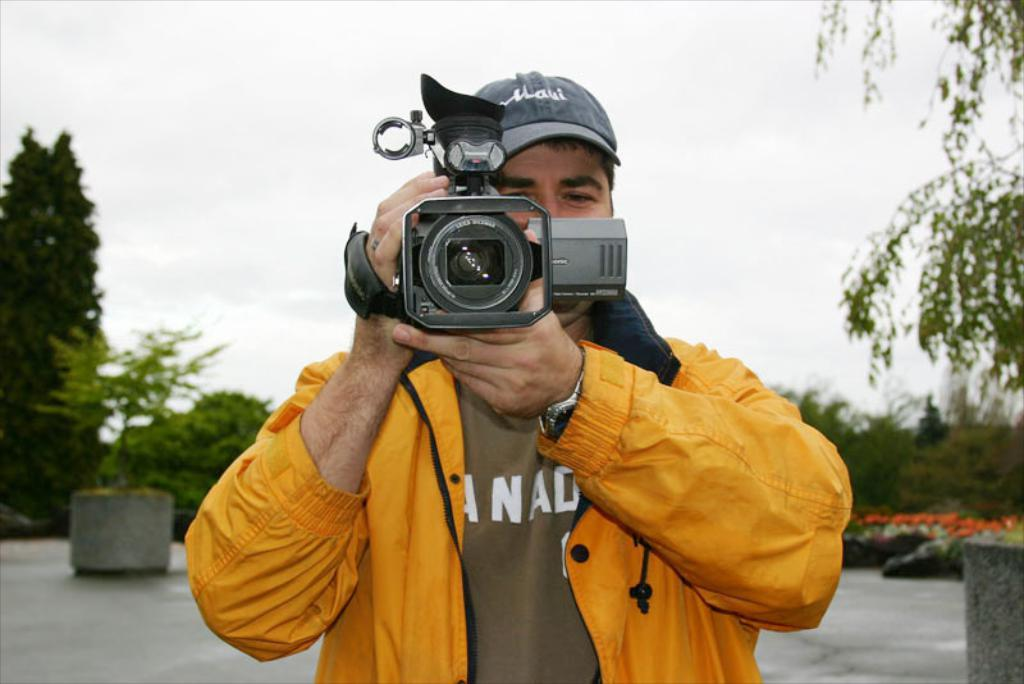What is the man in the image holding? The man is holding a camera in the image. What type of objects can be seen in the image related to plants? There are plants in pots and flowers visible in the image. What is the background of the image? The background of the image includes a group of trees and the sky. What is the condition of the sky in the image? The sky appears to be cloudy in the image. What type of whistle can be heard in the image? There is no whistle present in the image, and therefore no sound can be heard. What type of powder is being used by the man in the image? There is no powder visible or mentioned in the image; the man is holding a camera. 